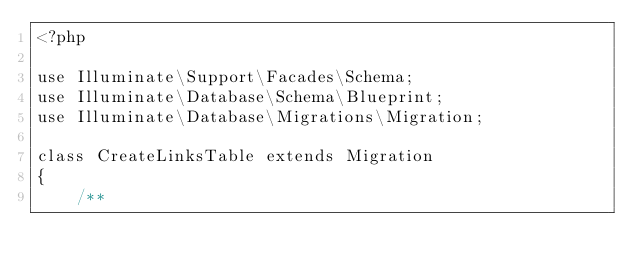<code> <loc_0><loc_0><loc_500><loc_500><_PHP_><?php

use Illuminate\Support\Facades\Schema;
use Illuminate\Database\Schema\Blueprint;
use Illuminate\Database\Migrations\Migration;

class CreateLinksTable extends Migration
{
    /**</code> 